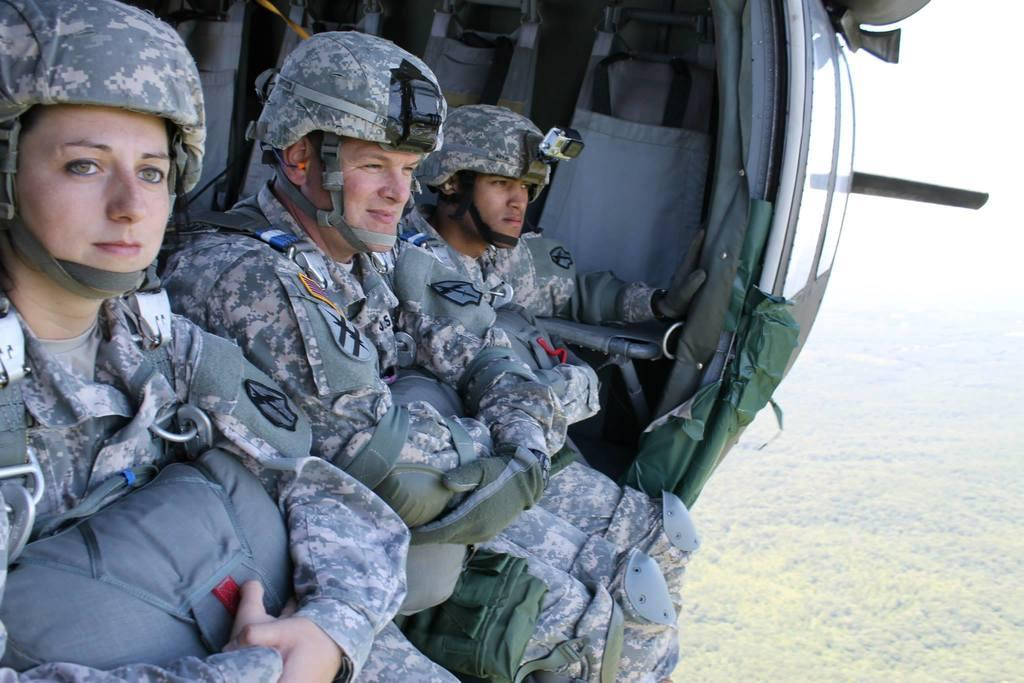How many people are inside the helicopter in the image? There are three people sitting inside the helicopter in the image. What can be seen behind the people inside the helicopter? There are seats behind the people inside the helicopter. What is visible in the background of the image? Trees and the sky are visible in the background of the image. What type of yak can be seen carrying a basket in the image? There is no yak or basket present in the image; it features a helicopter with people inside. What color is the powder that is being used by the people in the image? There is no powder present in the image; it features a helicopter with people inside. 